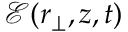<formula> <loc_0><loc_0><loc_500><loc_500>\mathcal { E } ( { r } _ { \perp } , z , t )</formula> 